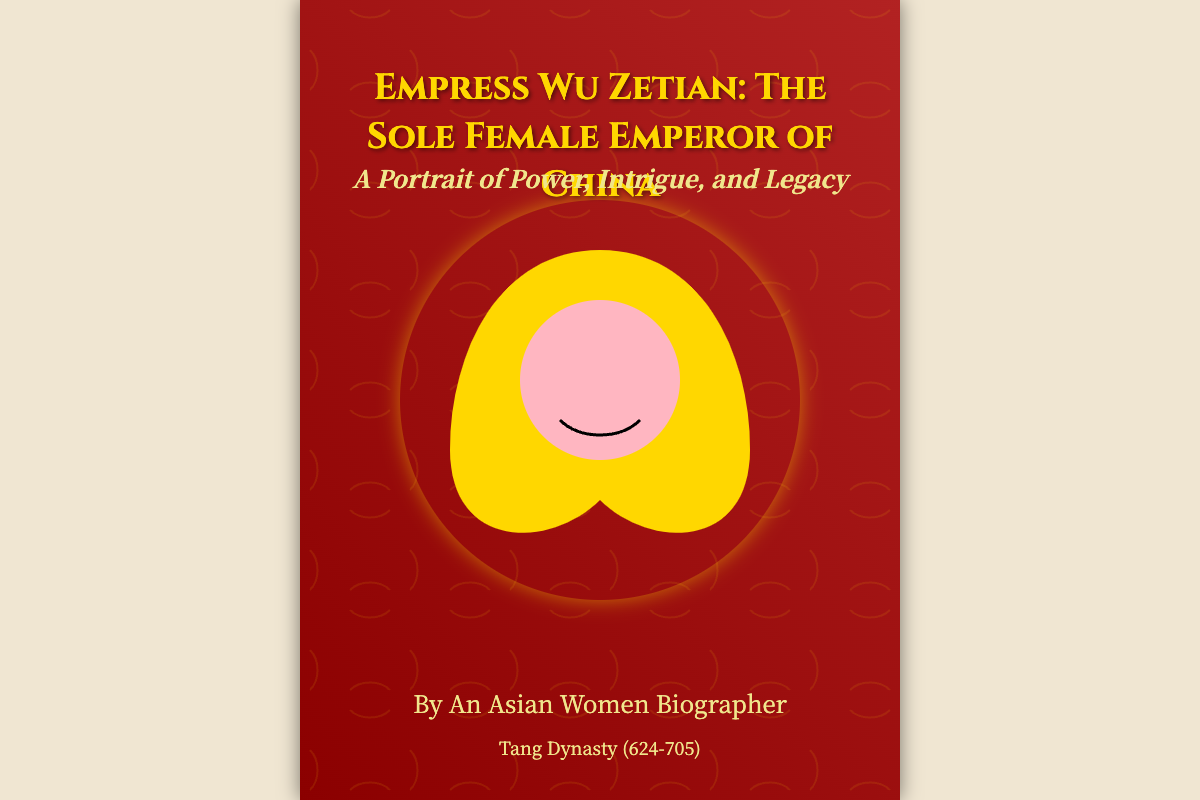What is the title of the book? The title of the book is stated prominently at the top of the cover.
Answer: Empress Wu Zetian: The Sole Female Emperor of China Who is the author? The author is mentioned at the bottom of the cover.
Answer: An Asian Women Biographer What is depicted in the background of the cover? The cover features delicate golden dragon motifs woven around the figure of Empress Wu Zetian.
Answer: Golden dragon motifs Which dynasty did Empress Wu Zetian belong to? The cover specifies the historical context of Empress Wu Zetian at the bottom.
Answer: Tang Dynasty What is the subtitle of the book? The subtitle is presented below the title, indicating the theme of the book.
Answer: A Portrait of Power, Intrigue, and Legacy What colors dominate the background of the book cover? The colors of the book cover are indicated by the linear color scheme used.
Answer: Dark red and light brown How many images or motifs are featured on the cover? There are primarily two design elements: the empress image and the dragon motifs.
Answer: Two What is the size dimension of the book cover? The dimensions of the book cover are implied through its design layout.
Answer: 600 x 800 pixels 